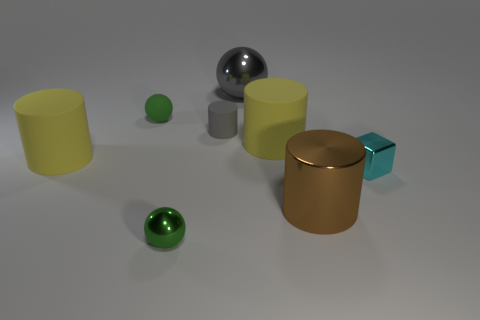Is the color of the metallic ball that is on the right side of the tiny gray matte object the same as the tiny ball behind the large brown metal object? No, the color of the metallic ball on the right side near the tiny gray object is silver, which differs from the tiny green ball behind the large brown metallic cylinder. These two balls have distinct colors: one exhibits a shiny metallic finish characteristic of reflective silver surfaces, while the other displays a green hue typical of colored glass or plastic. 